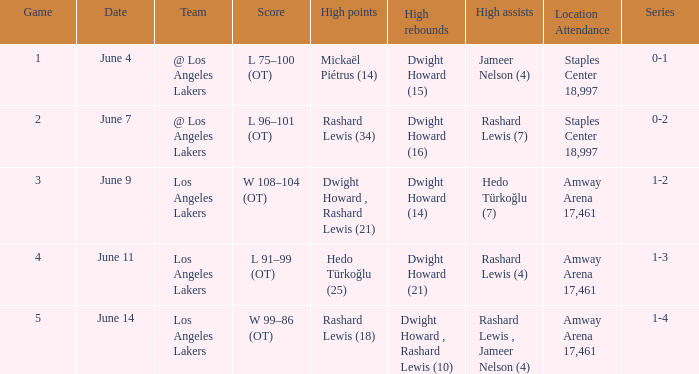What is High Points, when High Rebounds is "Dwight Howard (16)"? Rashard Lewis (34). 